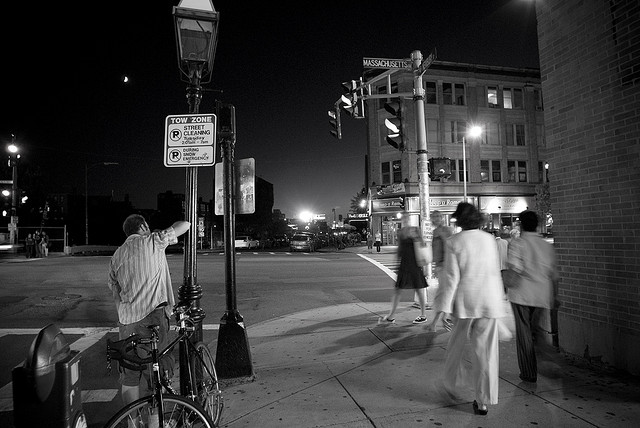Please transcribe the text in this image. TOW ZONE STREET MASSACHUSETTS R 